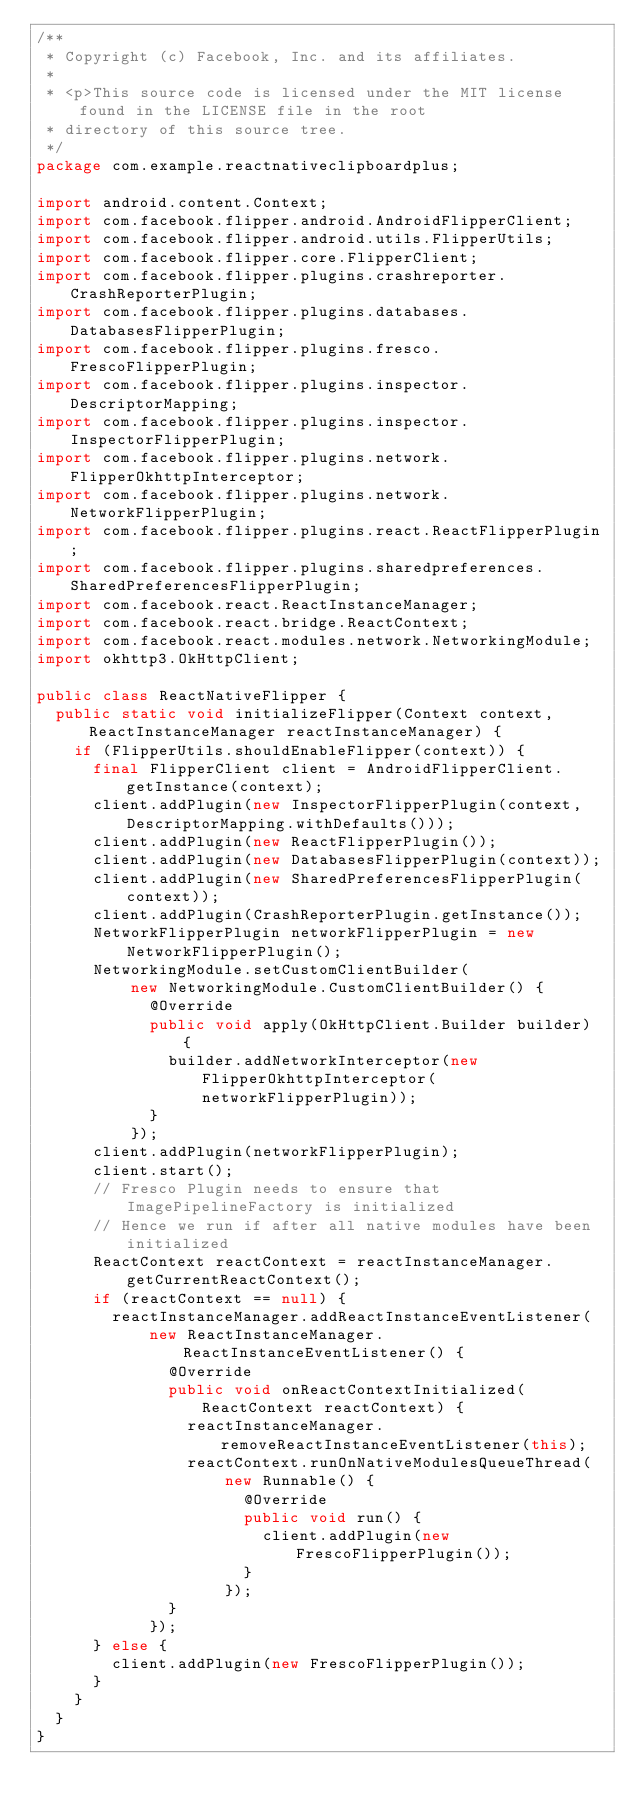<code> <loc_0><loc_0><loc_500><loc_500><_Java_>/**
 * Copyright (c) Facebook, Inc. and its affiliates.
 *
 * <p>This source code is licensed under the MIT license found in the LICENSE file in the root
 * directory of this source tree.
 */
package com.example.reactnativeclipboardplus;

import android.content.Context;
import com.facebook.flipper.android.AndroidFlipperClient;
import com.facebook.flipper.android.utils.FlipperUtils;
import com.facebook.flipper.core.FlipperClient;
import com.facebook.flipper.plugins.crashreporter.CrashReporterPlugin;
import com.facebook.flipper.plugins.databases.DatabasesFlipperPlugin;
import com.facebook.flipper.plugins.fresco.FrescoFlipperPlugin;
import com.facebook.flipper.plugins.inspector.DescriptorMapping;
import com.facebook.flipper.plugins.inspector.InspectorFlipperPlugin;
import com.facebook.flipper.plugins.network.FlipperOkhttpInterceptor;
import com.facebook.flipper.plugins.network.NetworkFlipperPlugin;
import com.facebook.flipper.plugins.react.ReactFlipperPlugin;
import com.facebook.flipper.plugins.sharedpreferences.SharedPreferencesFlipperPlugin;
import com.facebook.react.ReactInstanceManager;
import com.facebook.react.bridge.ReactContext;
import com.facebook.react.modules.network.NetworkingModule;
import okhttp3.OkHttpClient;

public class ReactNativeFlipper {
  public static void initializeFlipper(Context context, ReactInstanceManager reactInstanceManager) {
    if (FlipperUtils.shouldEnableFlipper(context)) {
      final FlipperClient client = AndroidFlipperClient.getInstance(context);
      client.addPlugin(new InspectorFlipperPlugin(context, DescriptorMapping.withDefaults()));
      client.addPlugin(new ReactFlipperPlugin());
      client.addPlugin(new DatabasesFlipperPlugin(context));
      client.addPlugin(new SharedPreferencesFlipperPlugin(context));
      client.addPlugin(CrashReporterPlugin.getInstance());
      NetworkFlipperPlugin networkFlipperPlugin = new NetworkFlipperPlugin();
      NetworkingModule.setCustomClientBuilder(
          new NetworkingModule.CustomClientBuilder() {
            @Override
            public void apply(OkHttpClient.Builder builder) {
              builder.addNetworkInterceptor(new FlipperOkhttpInterceptor(networkFlipperPlugin));
            }
          });
      client.addPlugin(networkFlipperPlugin);
      client.start();
      // Fresco Plugin needs to ensure that ImagePipelineFactory is initialized
      // Hence we run if after all native modules have been initialized
      ReactContext reactContext = reactInstanceManager.getCurrentReactContext();
      if (reactContext == null) {
        reactInstanceManager.addReactInstanceEventListener(
            new ReactInstanceManager.ReactInstanceEventListener() {
              @Override
              public void onReactContextInitialized(ReactContext reactContext) {
                reactInstanceManager.removeReactInstanceEventListener(this);
                reactContext.runOnNativeModulesQueueThread(
                    new Runnable() {
                      @Override
                      public void run() {
                        client.addPlugin(new FrescoFlipperPlugin());
                      }
                    });
              }
            });
      } else {
        client.addPlugin(new FrescoFlipperPlugin());
      }
    }
  }
}
</code> 